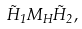<formula> <loc_0><loc_0><loc_500><loc_500>\tilde { H } _ { 1 } M _ { H } \tilde { H } _ { 2 } ,</formula> 